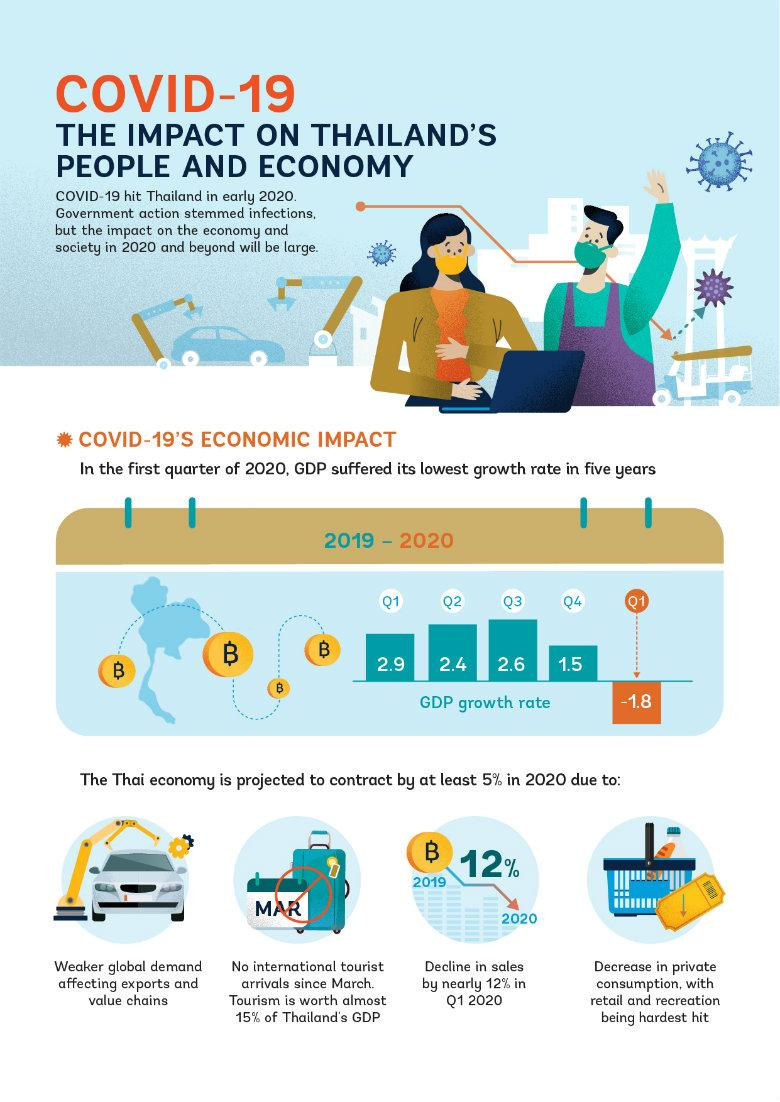Specify some key components in this picture. According to estimates, less than 15% of Thailand's Gross Domestic Product (GDP) is contributed by tourism. The highest GDP of Thailand was recorded in the third quarter of the year. 